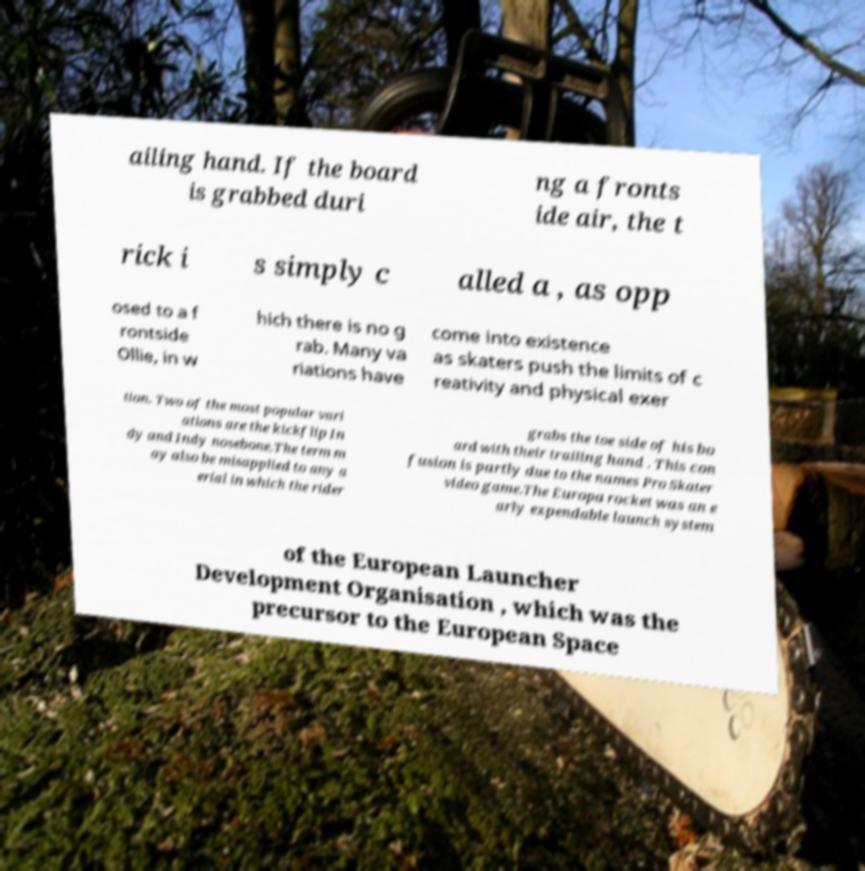Could you extract and type out the text from this image? ailing hand. If the board is grabbed duri ng a fronts ide air, the t rick i s simply c alled a , as opp osed to a f rontside Ollie, in w hich there is no g rab. Many va riations have come into existence as skaters push the limits of c reativity and physical exer tion. Two of the most popular vari ations are the kickflip In dy and Indy nosebone.The term m ay also be misapplied to any a erial in which the rider grabs the toe side of his bo ard with their trailing hand . This con fusion is partly due to the names Pro Skater video game.The Europa rocket was an e arly expendable launch system of the European Launcher Development Organisation , which was the precursor to the European Space 